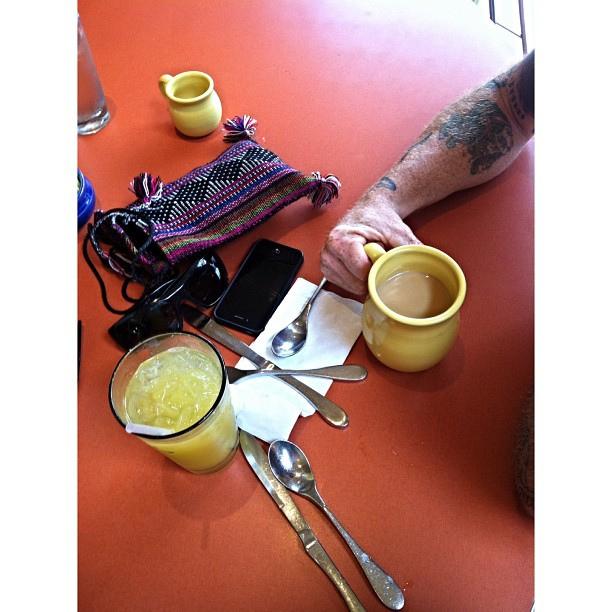Is this there an iPhone on the table?
Give a very brief answer. Yes. How many spoons are on the table?
Short answer required. 2. Are the liquid in the glass and the cup the same?
Short answer required. No. 